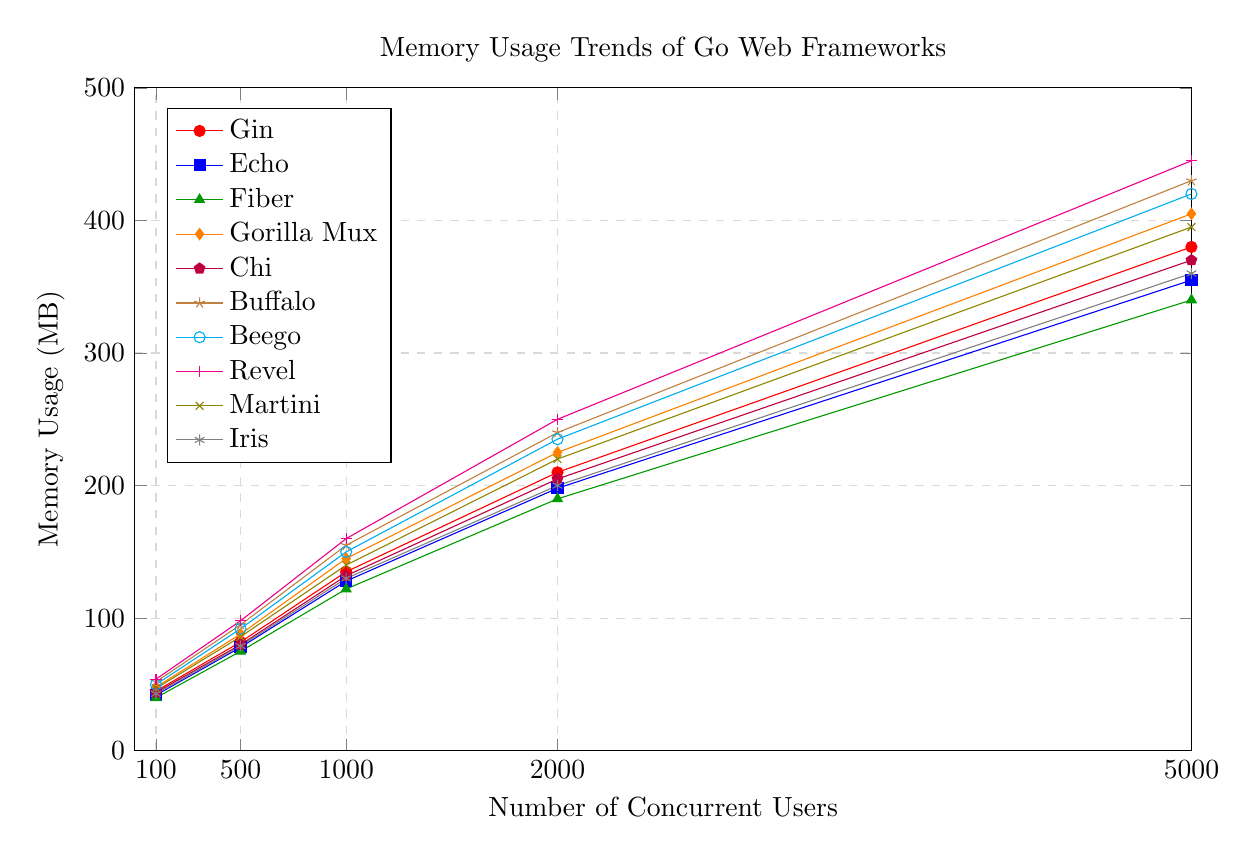What's the highest memory usage recorded in the figure and which framework does it correspond to? The highest memory usage can be determined by searching for the maximum value on the y-axis (Memory Usage) across all listed frameworks. By checking the highest points reached, we find that the maximum value is 445 MB for the framework Revel.
Answer: 445 MB, Revel Which two frameworks have the closest memory usage for 5000 concurrent users? To find the closest memory usage, compare the memory values for 5000 concurrent users across all frameworks. The closest values are 420 MB for Beego and 430 MB for Buffalo, showing a difference of 10 MB.
Answer: Beego, Buffalo What is the average memory usage for Echo across all the recorded user loads? Calculate the average by summing up Echo's memory usage at each concurrent user level and then dividing by the number of levels: (42 + 78 + 128 + 198 + 355) / 5 = 160.2 MB.
Answer: 160.2 MB Which framework shows the steepest increase in memory usage from 100 to 5000 concurrent users? To determine the steepest increase, we calculate the slope (difference) from 100 to 5000 concurrent users for each framework. The largest difference is shown by Revel, which increases from 54 MB to 445 MB, a difference of 391 MB.
Answer: Revel How does the memory usage of Gorilla Mux compare to Fiber at 1000 concurrent users? To compare, we look at the specific data points for 1000 concurrent users. Gorilla Mux uses 145 MB and Fiber uses 122 MB. Hence, Gorilla Mux uses more memory than Fiber at this point by 23 MB.
Answer: Gorilla Mux uses 23 MB more What's the visual relationship between the memory usages of Iris and Chi at 2000 concurrent users in terms of color and height? Visually, Iris is represented by a marker colored blue, and Chi is represented by a marker colored purple. At 2000 concurrent users, Iris's marker is slightly lower on the y-axis (200 MB) compared to Chi's marker (205 MB).
Answer: Iris (blue, lower), Chi (purple, higher) If you combine the memory usage of Gin and Buffalo at 1000 concurrent users, what would be the total? Sum the memory usage of Gin and Buffalo at 1000 concurrent users: Gin has 135 MB and Buffalo has 155 MB. The total is 135 + 155 = 290 MB.
Answer: 290 MB What is the median memory usage of all frameworks at 500 concurrent users? Find the middle value when all memory usages at 500 concurrent users are sorted: [75, 78, 79, 80, 82, 86, 88, 92, 95, 98]. The median is the average of the 5th and 6th values: (82 + 86) / 2 = 84 MB.
Answer: 84 MB What is the difference in memory usage between the framework with the highest and lowest memory usage at 2000 concurrent users? Identify the highest and lowest memory usage at 2000 concurrent users: Revel (250 MB) and Fiber (190 MB). The difference is 250 - 190 = 60 MB.
Answer: 60 MB 